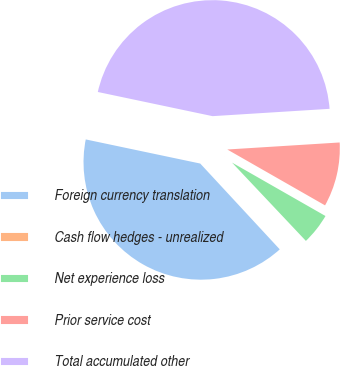<chart> <loc_0><loc_0><loc_500><loc_500><pie_chart><fcel>Foreign currency translation<fcel>Cash flow hedges - unrealized<fcel>Net experience loss<fcel>Prior service cost<fcel>Total accumulated other<nl><fcel>40.2%<fcel>0.14%<fcel>4.7%<fcel>9.26%<fcel>45.7%<nl></chart> 